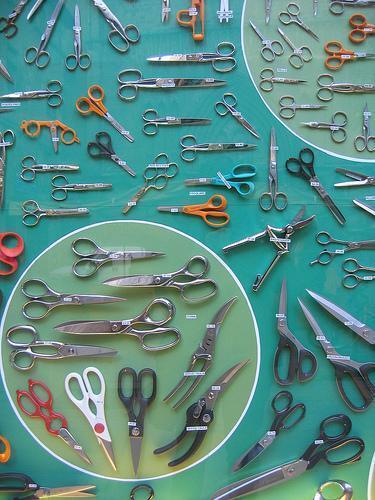How many pairs of scissors have orange handles?
Give a very brief answer. 7. How many scissors have red handles?
Give a very brief answer. 1. How many handles are blue?
Give a very brief answer. 1. How many scissors have white handles in the photo?
Give a very brief answer. 1. How many scissors have blue handles?
Give a very brief answer. 1. 